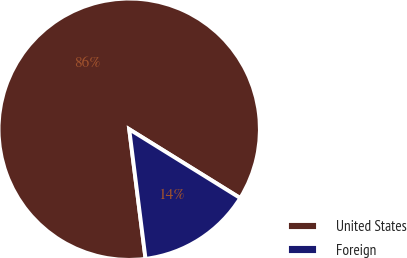Convert chart. <chart><loc_0><loc_0><loc_500><loc_500><pie_chart><fcel>United States<fcel>Foreign<nl><fcel>85.83%<fcel>14.17%<nl></chart> 